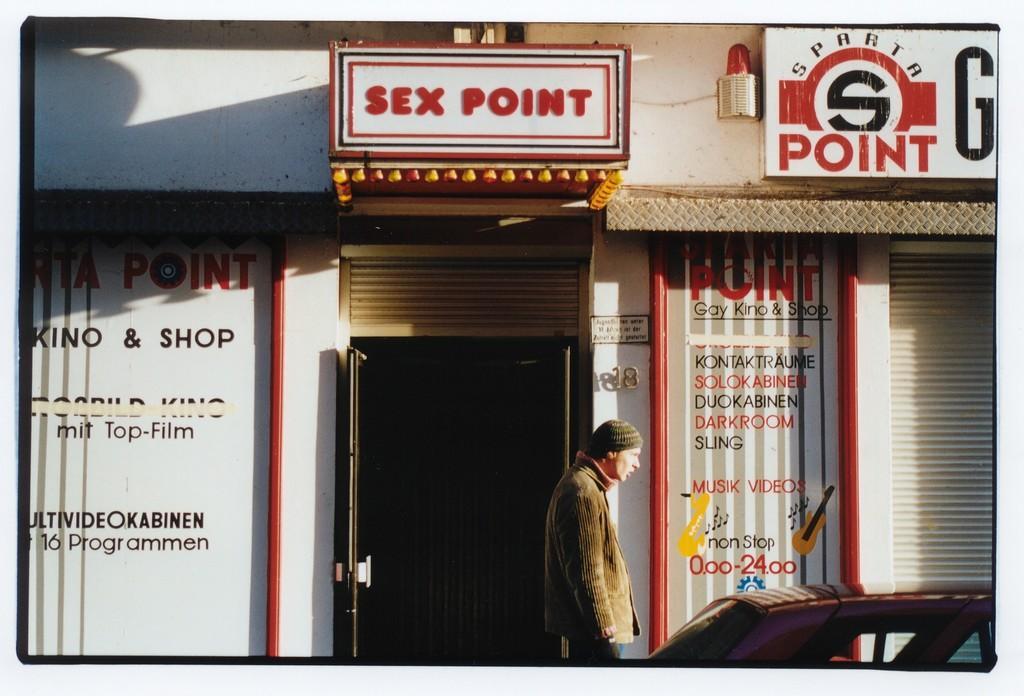How would you summarize this image in a sentence or two? In the image there is a man standing in front of a store with a car on the right side. 